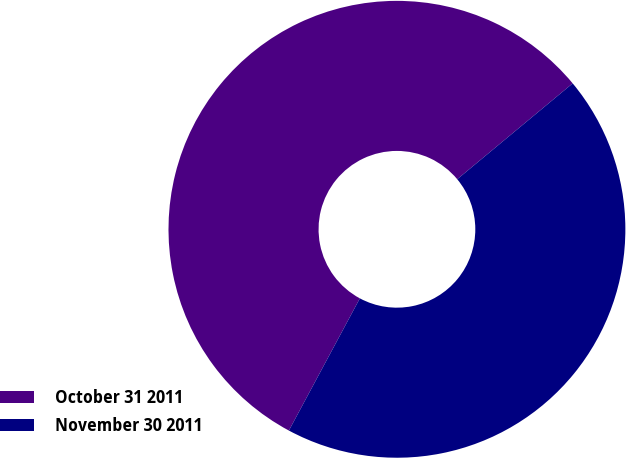Convert chart. <chart><loc_0><loc_0><loc_500><loc_500><pie_chart><fcel>October 31 2011<fcel>November 30 2011<nl><fcel>56.13%<fcel>43.87%<nl></chart> 